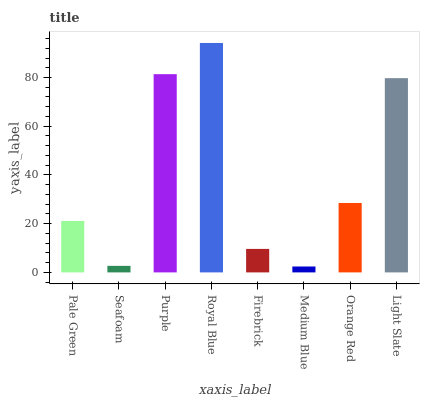Is Seafoam the minimum?
Answer yes or no. No. Is Seafoam the maximum?
Answer yes or no. No. Is Pale Green greater than Seafoam?
Answer yes or no. Yes. Is Seafoam less than Pale Green?
Answer yes or no. Yes. Is Seafoam greater than Pale Green?
Answer yes or no. No. Is Pale Green less than Seafoam?
Answer yes or no. No. Is Orange Red the high median?
Answer yes or no. Yes. Is Pale Green the low median?
Answer yes or no. Yes. Is Light Slate the high median?
Answer yes or no. No. Is Royal Blue the low median?
Answer yes or no. No. 